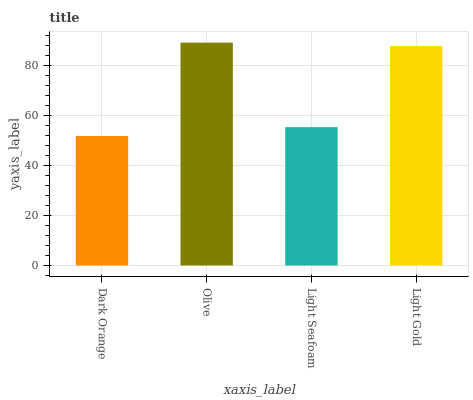Is Dark Orange the minimum?
Answer yes or no. Yes. Is Olive the maximum?
Answer yes or no. Yes. Is Light Seafoam the minimum?
Answer yes or no. No. Is Light Seafoam the maximum?
Answer yes or no. No. Is Olive greater than Light Seafoam?
Answer yes or no. Yes. Is Light Seafoam less than Olive?
Answer yes or no. Yes. Is Light Seafoam greater than Olive?
Answer yes or no. No. Is Olive less than Light Seafoam?
Answer yes or no. No. Is Light Gold the high median?
Answer yes or no. Yes. Is Light Seafoam the low median?
Answer yes or no. Yes. Is Light Seafoam the high median?
Answer yes or no. No. Is Dark Orange the low median?
Answer yes or no. No. 